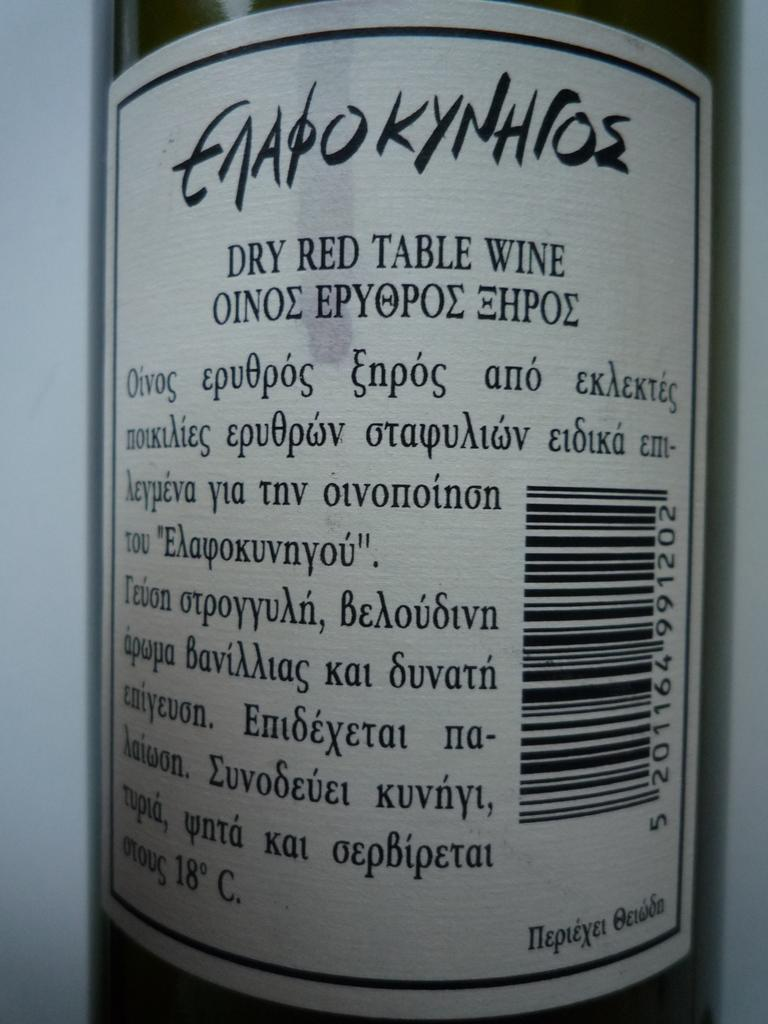<image>
Write a terse but informative summary of the picture. The back of a wine bottle written in a different language 